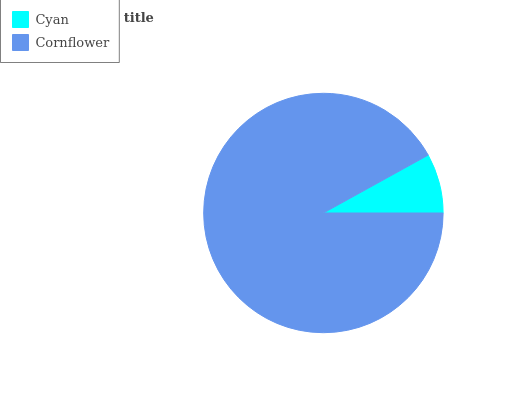Is Cyan the minimum?
Answer yes or no. Yes. Is Cornflower the maximum?
Answer yes or no. Yes. Is Cornflower the minimum?
Answer yes or no. No. Is Cornflower greater than Cyan?
Answer yes or no. Yes. Is Cyan less than Cornflower?
Answer yes or no. Yes. Is Cyan greater than Cornflower?
Answer yes or no. No. Is Cornflower less than Cyan?
Answer yes or no. No. Is Cornflower the high median?
Answer yes or no. Yes. Is Cyan the low median?
Answer yes or no. Yes. Is Cyan the high median?
Answer yes or no. No. Is Cornflower the low median?
Answer yes or no. No. 